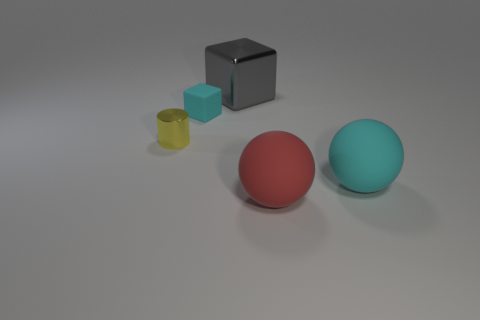Is the material of the red ball the same as the cylinder?
Provide a short and direct response. No. The red thing that is the same shape as the big cyan rubber object is what size?
Make the answer very short. Large. What number of objects are cyan cubes to the left of the gray metallic cube or tiny things that are behind the shiny cylinder?
Your answer should be very brief. 1. Is the number of purple rubber things less than the number of tiny yellow things?
Give a very brief answer. Yes. Does the cyan rubber ball have the same size as the metallic thing that is behind the metallic cylinder?
Offer a very short reply. Yes. What number of rubber things are either big red blocks or small yellow cylinders?
Provide a succinct answer. 0. Is the number of shiny blocks greater than the number of big brown cylinders?
Offer a terse response. Yes. The ball that is the same color as the small rubber thing is what size?
Offer a terse response. Large. There is a matte thing that is in front of the sphere that is to the right of the big red matte object; what is its shape?
Your answer should be compact. Sphere. There is a cyan rubber object in front of the tiny cyan rubber cube that is right of the cylinder; are there any large red rubber balls behind it?
Your answer should be very brief. No. 